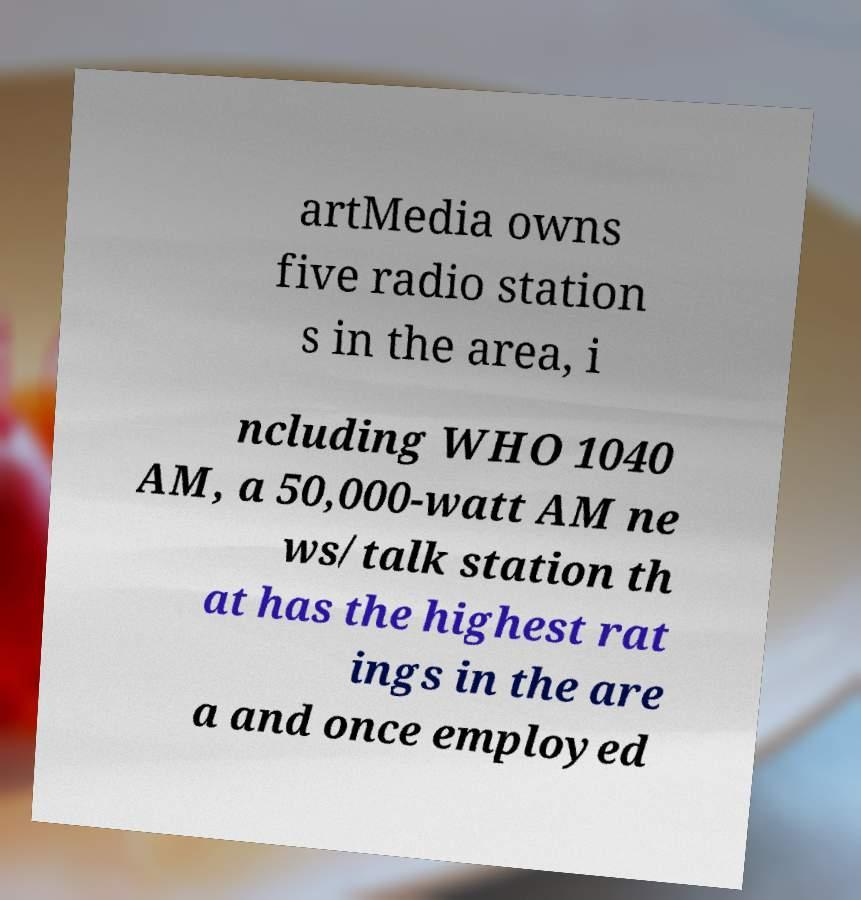For documentation purposes, I need the text within this image transcribed. Could you provide that? artMedia owns five radio station s in the area, i ncluding WHO 1040 AM, a 50,000-watt AM ne ws/talk station th at has the highest rat ings in the are a and once employed 